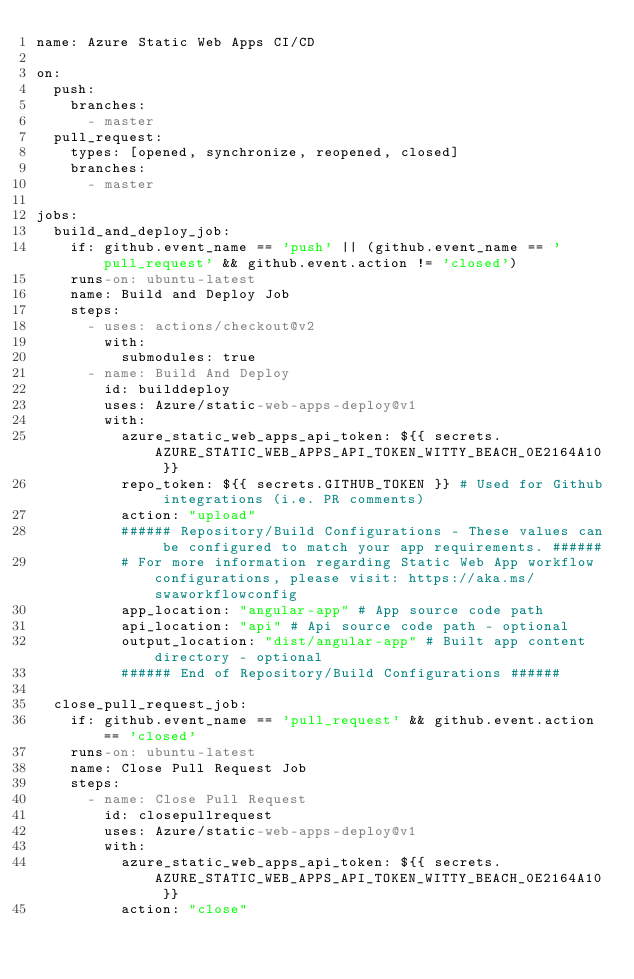Convert code to text. <code><loc_0><loc_0><loc_500><loc_500><_YAML_>name: Azure Static Web Apps CI/CD

on:
  push:
    branches:
      - master
  pull_request:
    types: [opened, synchronize, reopened, closed]
    branches:
      - master

jobs:
  build_and_deploy_job:
    if: github.event_name == 'push' || (github.event_name == 'pull_request' && github.event.action != 'closed')
    runs-on: ubuntu-latest
    name: Build and Deploy Job
    steps:
      - uses: actions/checkout@v2
        with:
          submodules: true
      - name: Build And Deploy
        id: builddeploy
        uses: Azure/static-web-apps-deploy@v1
        with:
          azure_static_web_apps_api_token: ${{ secrets.AZURE_STATIC_WEB_APPS_API_TOKEN_WITTY_BEACH_0E2164A10 }}
          repo_token: ${{ secrets.GITHUB_TOKEN }} # Used for Github integrations (i.e. PR comments)
          action: "upload"
          ###### Repository/Build Configurations - These values can be configured to match your app requirements. ######
          # For more information regarding Static Web App workflow configurations, please visit: https://aka.ms/swaworkflowconfig
          app_location: "angular-app" # App source code path
          api_location: "api" # Api source code path - optional
          output_location: "dist/angular-app" # Built app content directory - optional
          ###### End of Repository/Build Configurations ######

  close_pull_request_job:
    if: github.event_name == 'pull_request' && github.event.action == 'closed'
    runs-on: ubuntu-latest
    name: Close Pull Request Job
    steps:
      - name: Close Pull Request
        id: closepullrequest
        uses: Azure/static-web-apps-deploy@v1
        with:
          azure_static_web_apps_api_token: ${{ secrets.AZURE_STATIC_WEB_APPS_API_TOKEN_WITTY_BEACH_0E2164A10 }}
          action: "close"
</code> 